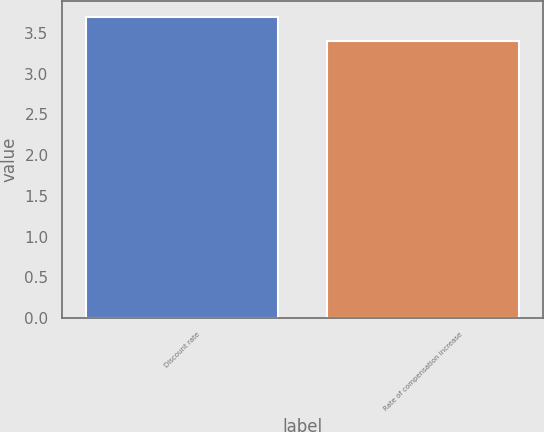Convert chart. <chart><loc_0><loc_0><loc_500><loc_500><bar_chart><fcel>Discount rate<fcel>Rate of compensation increase<nl><fcel>3.7<fcel>3.4<nl></chart> 